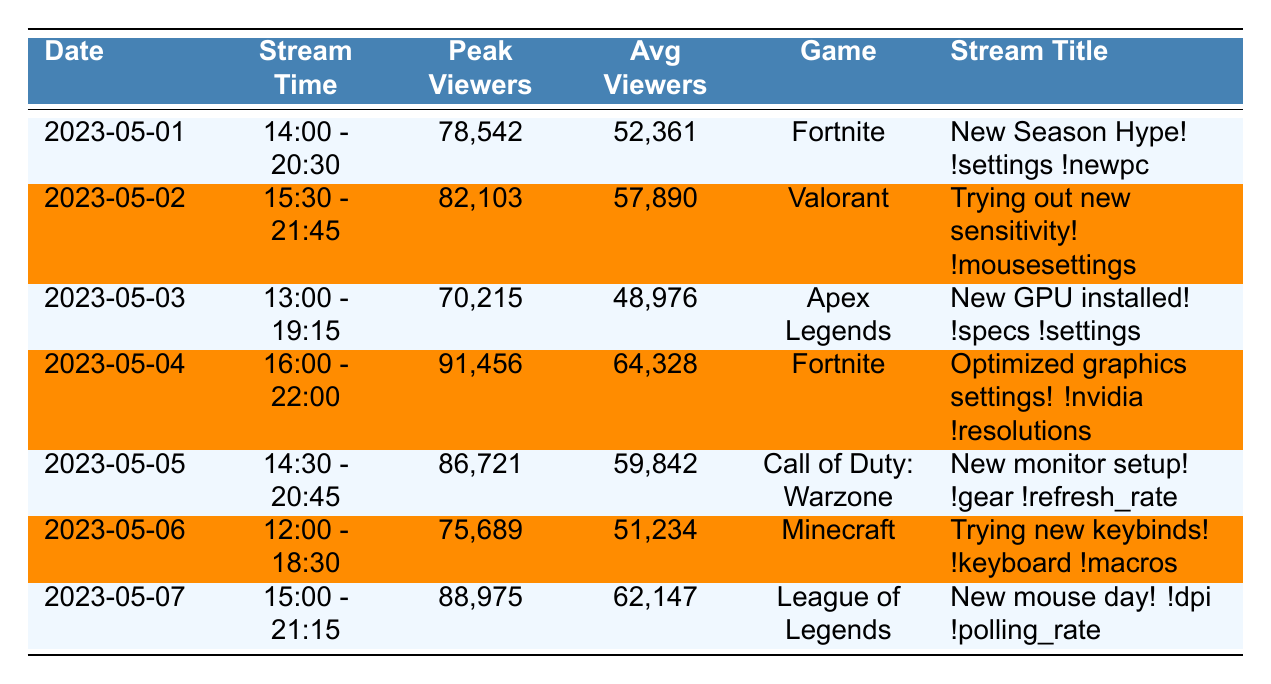What was the peak viewer count on May 4, 2023? The table lists the peak viewers for each date. On May 4, 2023, the peak viewer count was noted as 91,456.
Answer: 91,456 What game was streamed on May 2, 2023? The game played on each date is listed in the table. For May 2, 2023, the game streamed was Valorant.
Answer: Valorant Which date had the highest average viewers? By comparing the average viewers for all dates, May 4, 2023 had the highest average with 64,328.
Answer: May 4, 2023 Did Ninja gain more than 1500 subscribers on May 2, 2023? The table states that Ninja gained 1,532 subscribers on this date, which is more than 1,500.
Answer: Yes What is the total number of subscribers gained over the week? To find the total, sum the subscribers gained from each day: 1245 + 1532 + 987 + 1876 + 1654 + 1123 + 1789 = 10306.
Answer: 10306 What was the average peak viewer count across all streams? The peak viewers for the seven days are 78,542, 82,103, 70,215, 91,456, 86,721, 75,689, and 88,975. After summing these (i.e., 78,542 + 82,103 + 70,215 + 91,456 + 86,721 + 75,689 + 88,975) = 583,701 and dividing by 7 gives an average of 83,386.
Answer: 83,386 On which day was the stream titled "Trying new keybinds!"? Checking the stream titles, "Trying new keybinds!" was streamed on May 6, 2023.
Answer: May 6, 2023 Was the average viewership on May 5, 2023 higher than on May 6, 2023? For May 5, the average viewers were 59,842, and for May 6, they were 51,234. Since 59,842 > 51,234, it is higher.
Answer: Yes What was the difference in peak viewers between May 1 and May 3, 2023? The peak viewers for May 1, 2023, were 78,542 and for May 3, 2023, were 70,215. The difference is 78,542 - 70,215 = 8,327.
Answer: 8,327 Which game did Ninja play for the longest duration based on stream times? By examining the end and start times, May 4, 2023 had the longest stream from 16:00 to 22:00, lasting 6 hours.
Answer: May 4, 2023 (Fortnite) How many games were streamed during this week? The table lists different games: Fortnite, Valorant, Apex Legends, Call of Duty: Warzone, Minecraft, and League of Legends. That counts as six unique games streamed throughout the week.
Answer: 6 